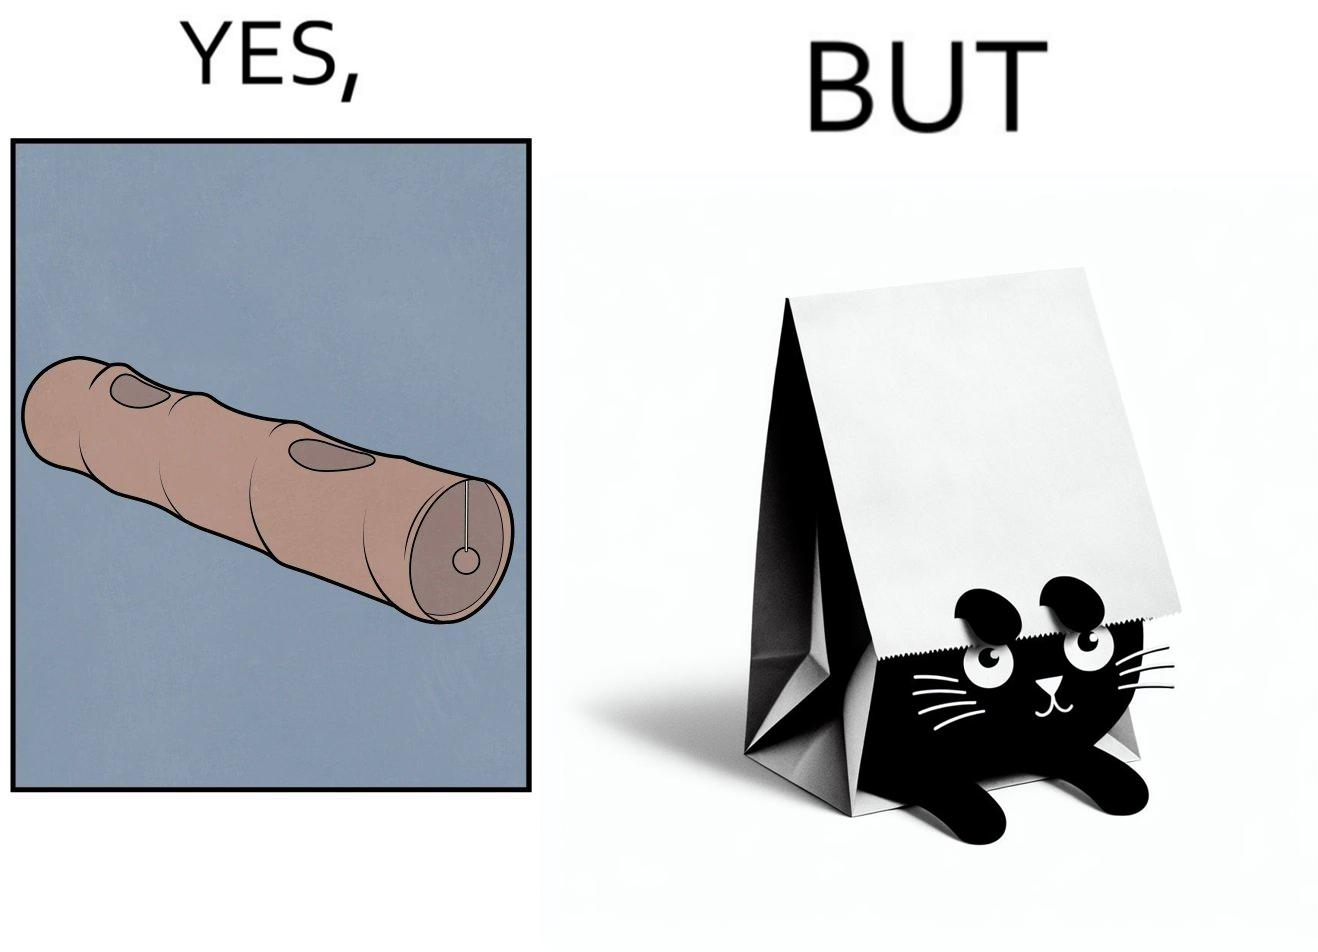What is shown in the left half versus the right half of this image? In the left part of the image: a long piece of cylinder with two circular holes over its surface and two holes at top and bottom and a hanging toy at one end In the right part of the image: an animal hiding its face in a paper bag, probably a cat or dog 